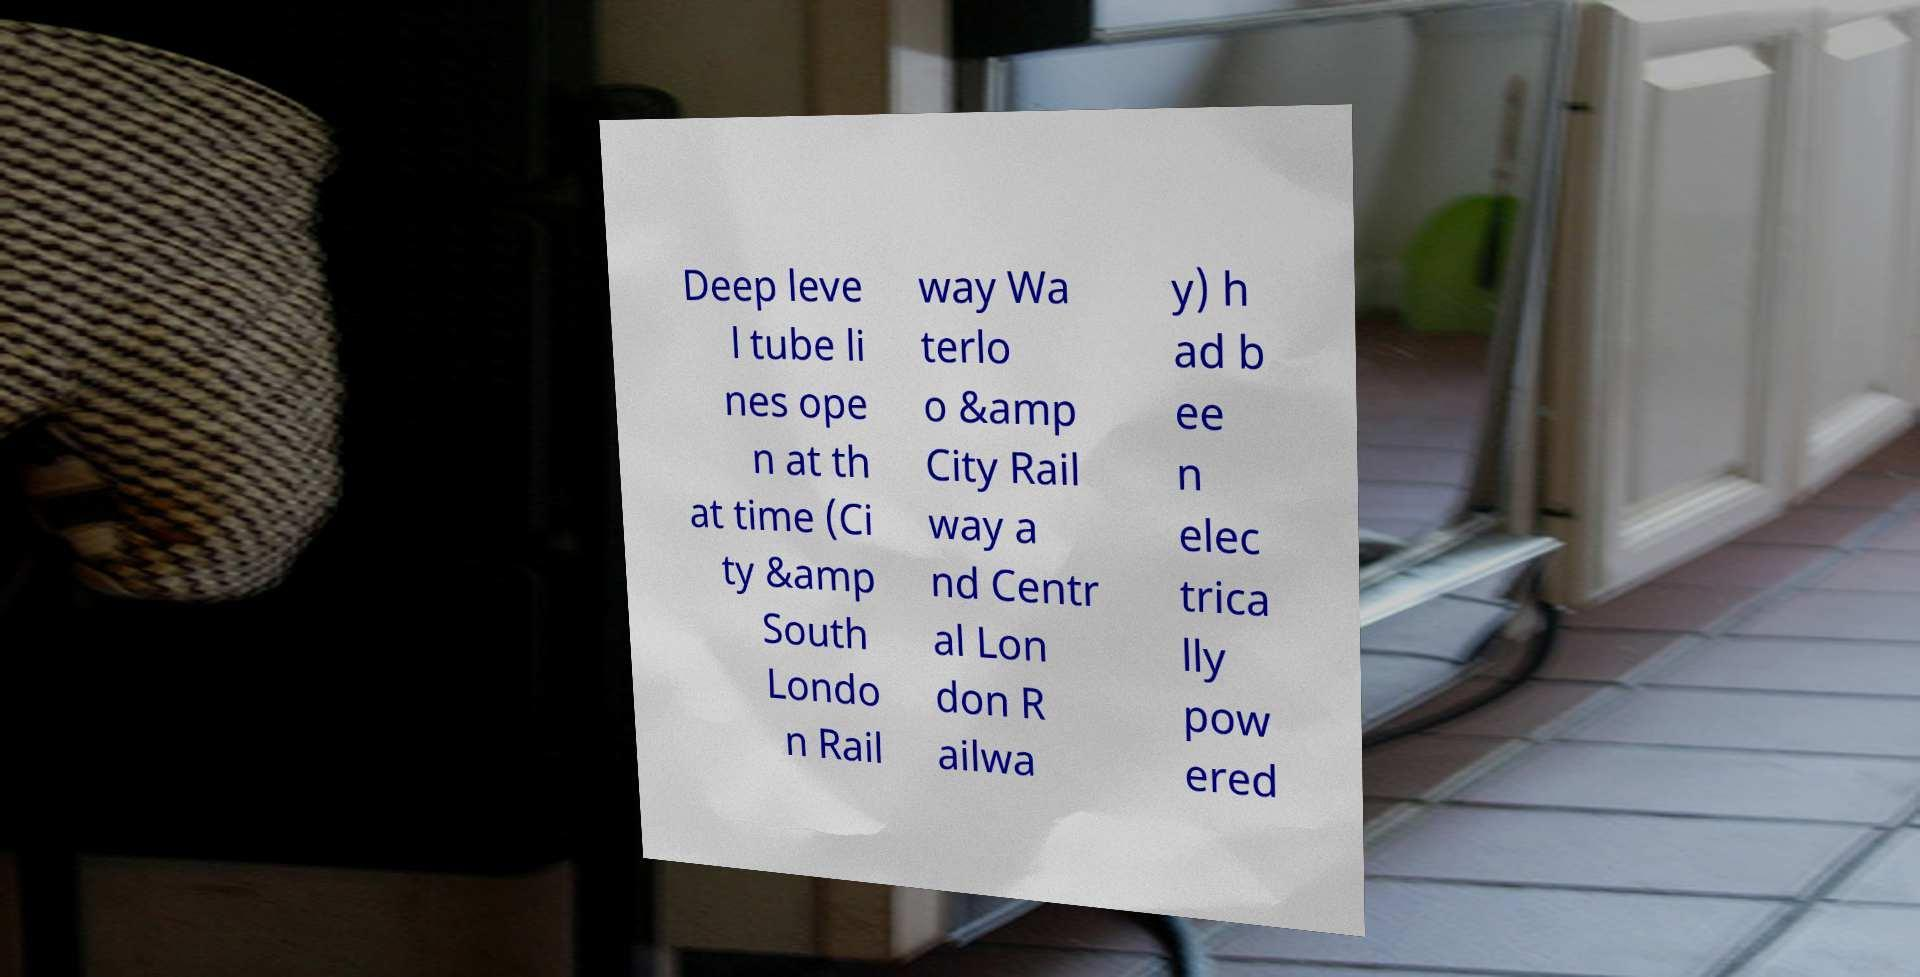Could you extract and type out the text from this image? Deep leve l tube li nes ope n at th at time (Ci ty &amp South Londo n Rail way Wa terlo o &amp City Rail way a nd Centr al Lon don R ailwa y) h ad b ee n elec trica lly pow ered 